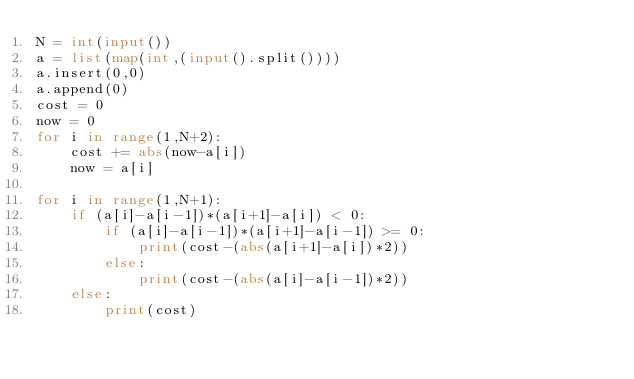Convert code to text. <code><loc_0><loc_0><loc_500><loc_500><_Python_>N = int(input())
a = list(map(int,(input().split())))
a.insert(0,0)
a.append(0)
cost = 0
now = 0
for i in range(1,N+2):
    cost += abs(now-a[i])
    now = a[i]

for i in range(1,N+1):
    if (a[i]-a[i-1])*(a[i+1]-a[i]) < 0:
        if (a[i]-a[i-1])*(a[i+1]-a[i-1]) >= 0:
            print(cost-(abs(a[i+1]-a[i])*2))
        else:
            print(cost-(abs(a[i]-a[i-1])*2))
    else:
        print(cost)</code> 